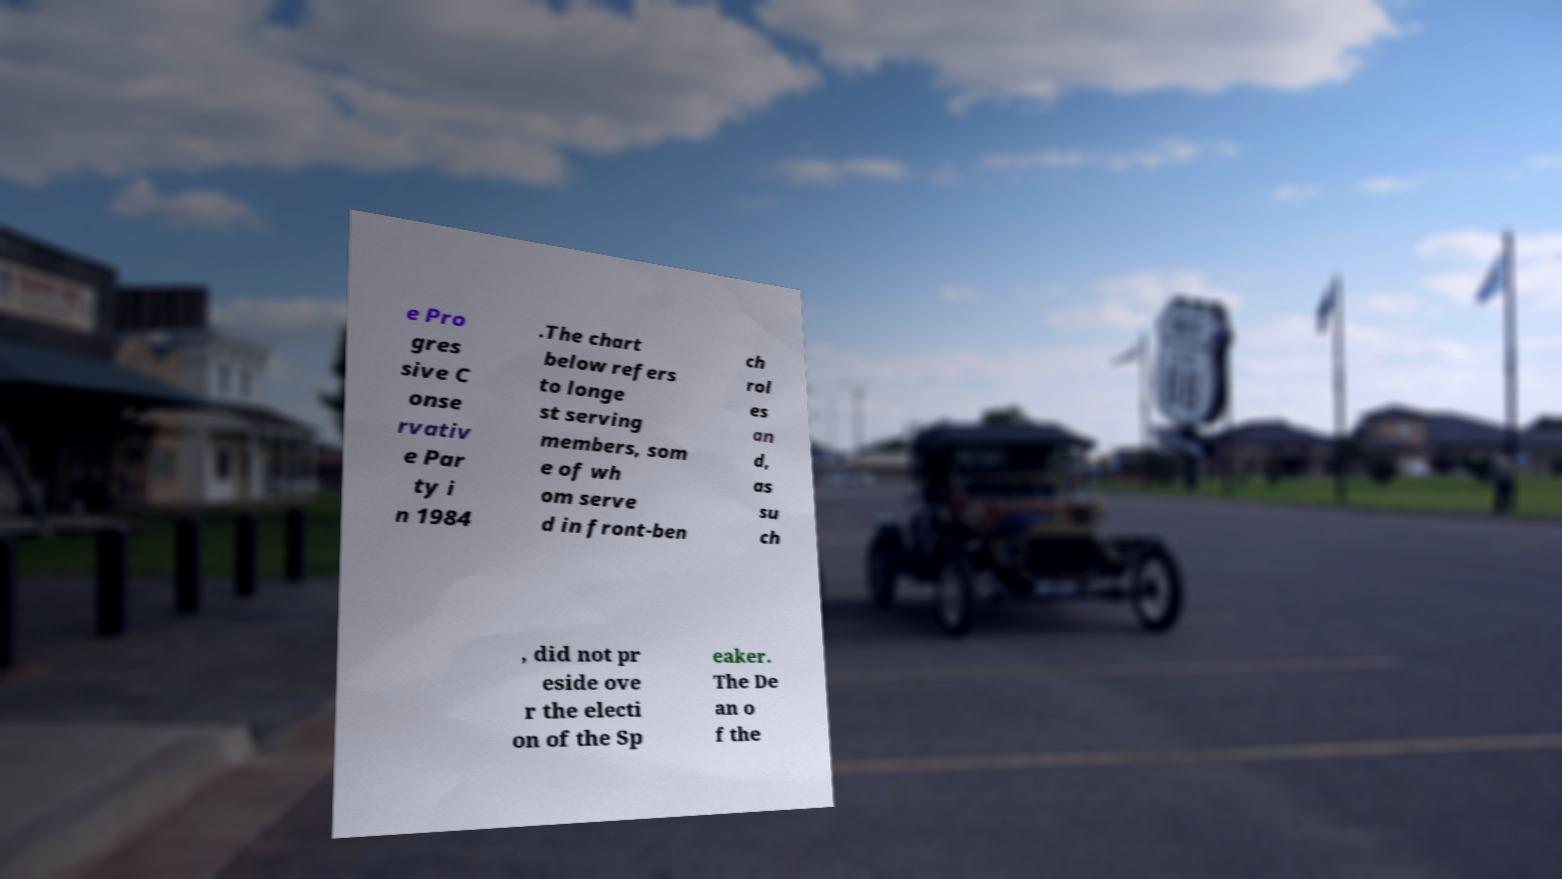Please identify and transcribe the text found in this image. e Pro gres sive C onse rvativ e Par ty i n 1984 .The chart below refers to longe st serving members, som e of wh om serve d in front-ben ch rol es an d, as su ch , did not pr eside ove r the electi on of the Sp eaker. The De an o f the 